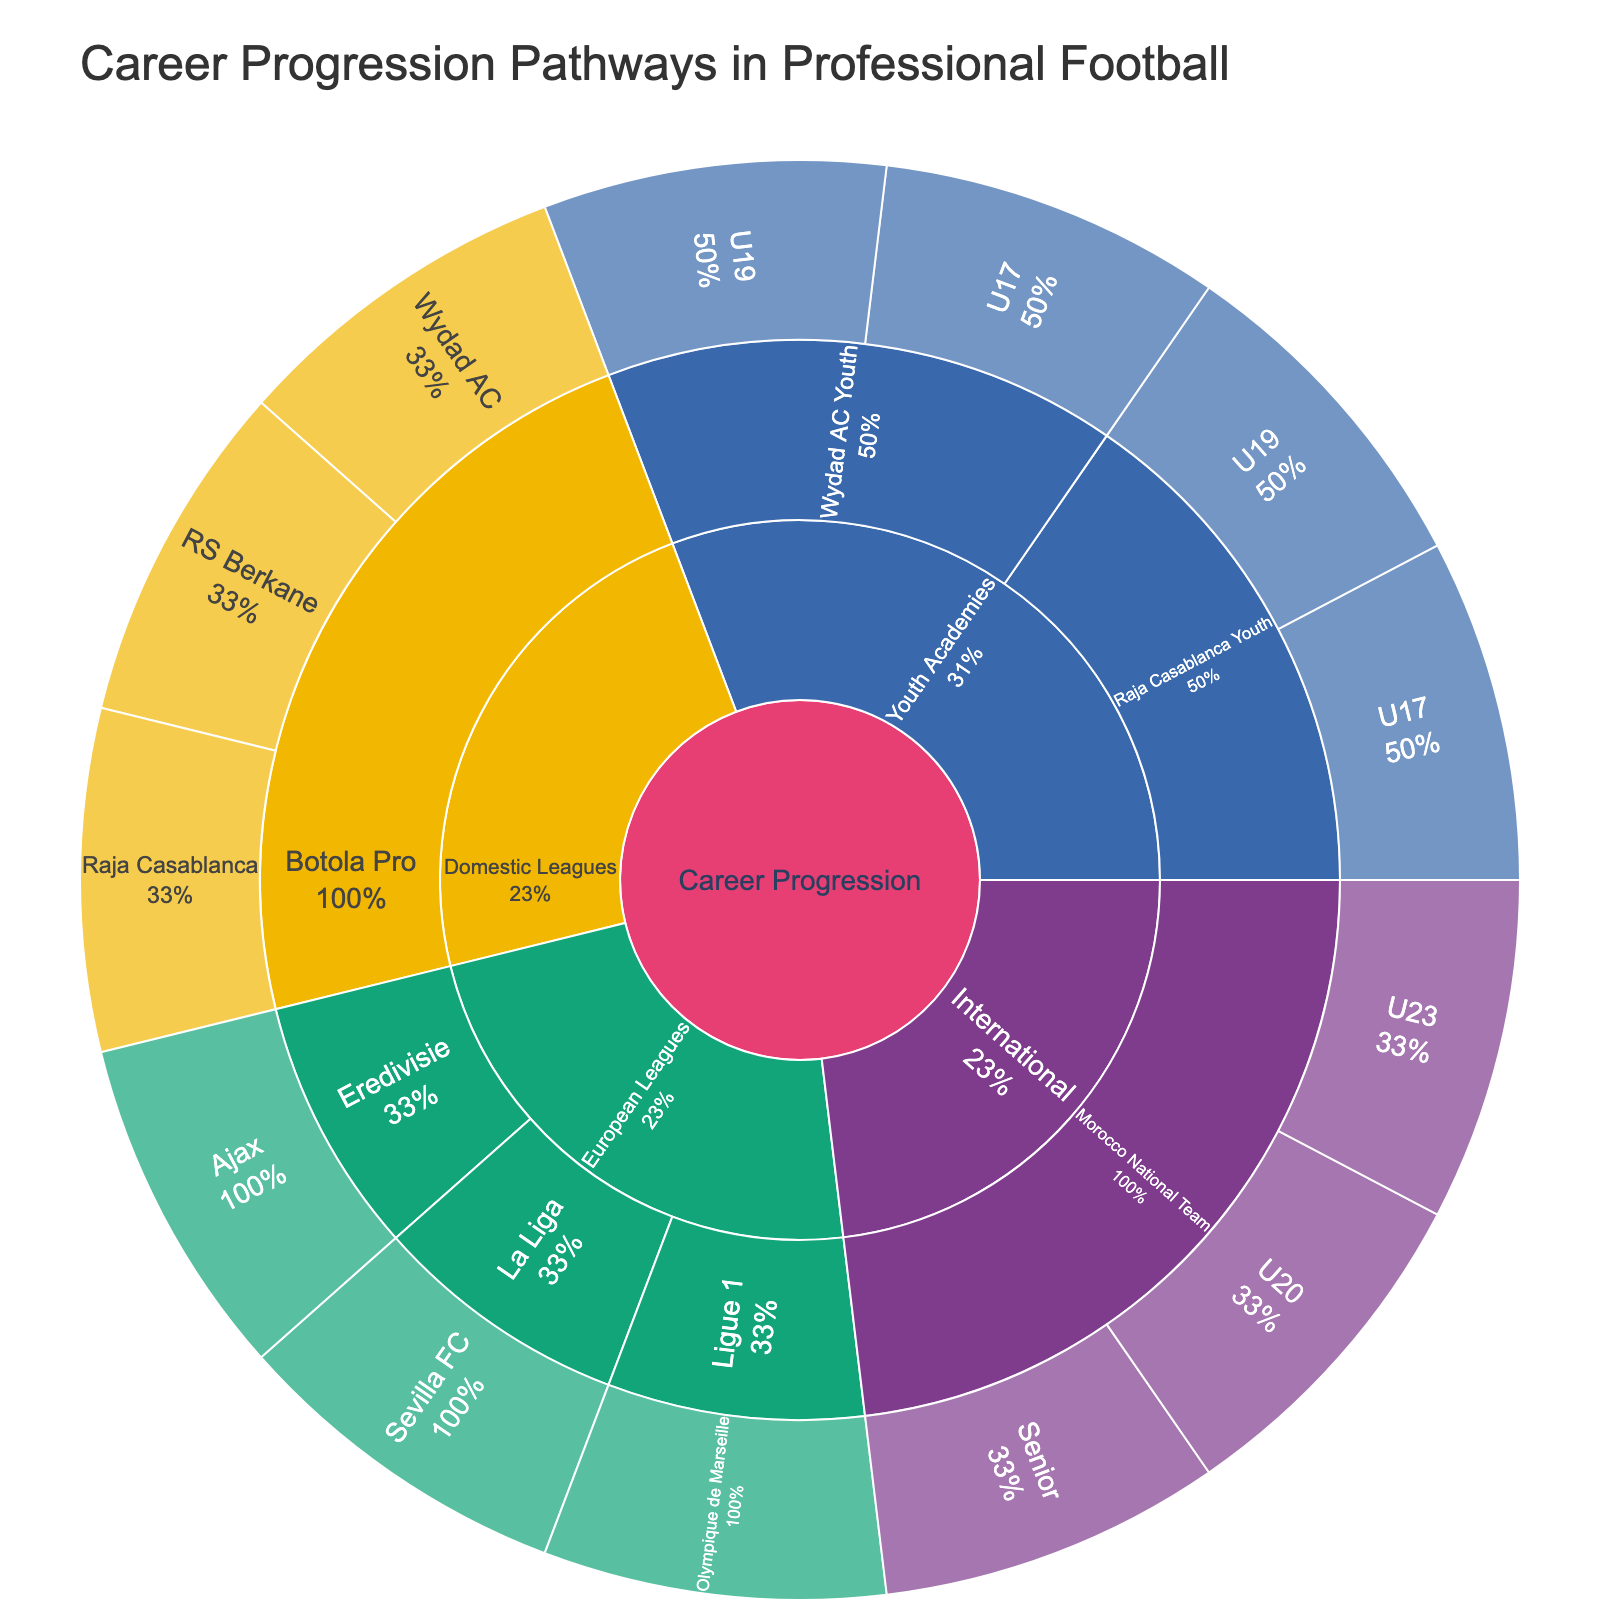What is the title of the Sunburst Plot? The title is usually displayed at the top of the figure. In this case, it highlights the main purpose of the Sunburst Plot.
Answer: Career Progression Pathways in Professional Football How many levels are there in the Sunburst Plot? Examining the figure, you can see the hierarchical structure originating from the center. Each concentric circle represents a different level.
Answer: Four levels Which Moroccan clubs are represented at the youth academy level in the plot? We need to look at the "Youth Academies" section and see the clubs associated with it at the next level.
Answer: Wydad AC Youth and Raja Casablanca Youth How many unique European leagues are shown in the plot? By identifying the branches under "European Leagues" and counting them, we determine the number of unique leagues.
Answer: Three What is the percentage representation for Raja Casablanca’s youth teams in the plot? To find this, we need to look at the segments labeled "Raja Casablanca Youth" under "Youth Academies" and check the percentage indicated.
Answer: This depends on the actual diagram, but the segments representing U17 and U19 together would show this Which national levels are represented in the international section for Morocco? Under 'International', examine the branches that represent Morocco's national team at different levels.
Answer: U20, U23, Senior Compare the levels available for the Morocco National Team and Wydad AC Youth. Which has more levels represented? Count the sublevels under "Morocco National Team" and "Wydad AC Youth", then compare the totals.
Answer: Morocco National Team Which section contains 'Ajax'? Trace where 'Ajax' appears in the hierarchy, starting from the root and moving through the levels.
Answer: European Leagues > Eredivisie How many professional Moroccan clubs are represented in the domestic leagues section? Examine the branches under "Domestic Leagues" and count the Moroccan clubs listed.
Answer: Three What does the smallest percentage in the plot represent? Identify the smallest segment in the plot and check its label and percentage, which indicates its relative size.
Answer: This will vary based on the actual segments and percentages shown but should be a specific youth or club team 